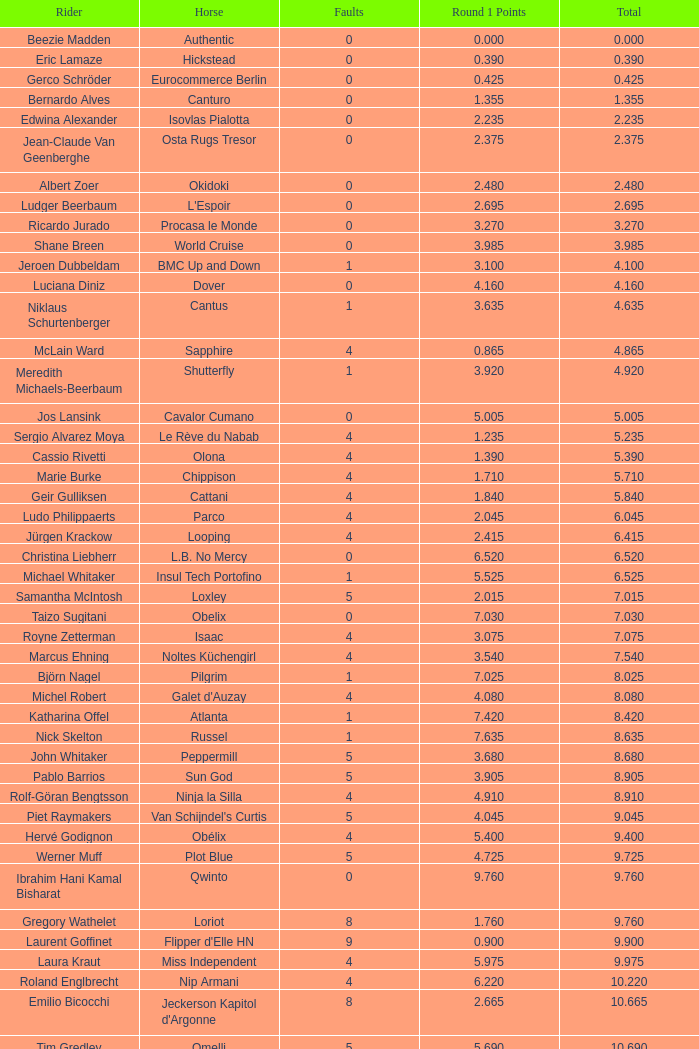What is carlson's horse's maximum total? 29.545. 